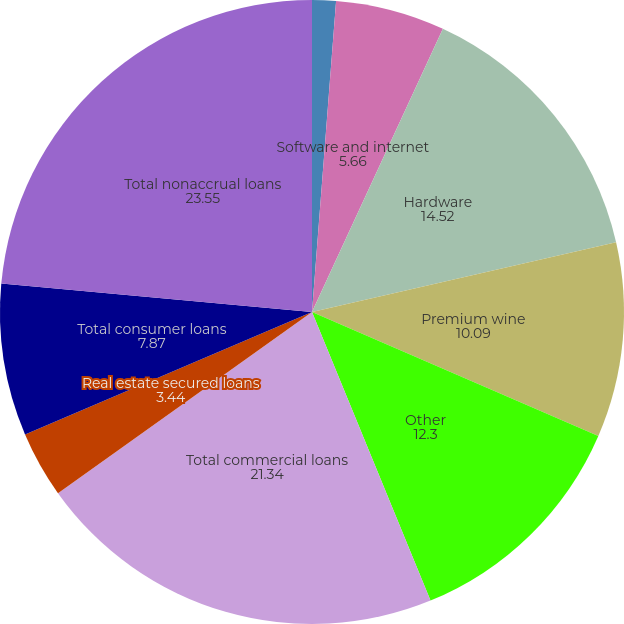Convert chart to OTSL. <chart><loc_0><loc_0><loc_500><loc_500><pie_chart><fcel>(Dollars in thousands)<fcel>Software and internet<fcel>Hardware<fcel>Premium wine<fcel>Other<fcel>Total commercial loans<fcel>Real estate secured loans<fcel>Total consumer loans<fcel>Total nonaccrual loans<nl><fcel>1.23%<fcel>5.66%<fcel>14.52%<fcel>10.09%<fcel>12.3%<fcel>21.34%<fcel>3.44%<fcel>7.87%<fcel>23.55%<nl></chart> 